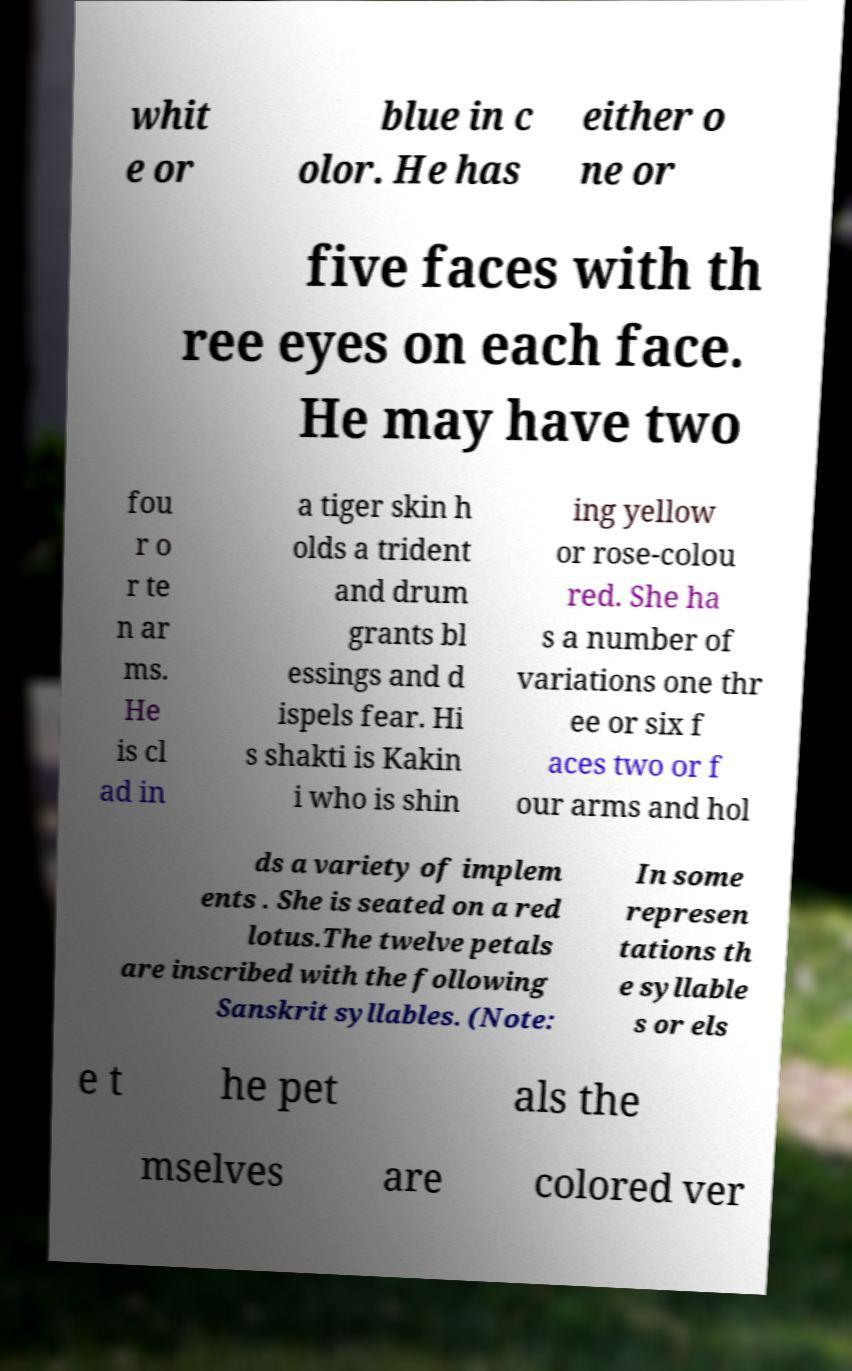Please identify and transcribe the text found in this image. whit e or blue in c olor. He has either o ne or five faces with th ree eyes on each face. He may have two fou r o r te n ar ms. He is cl ad in a tiger skin h olds a trident and drum grants bl essings and d ispels fear. Hi s shakti is Kakin i who is shin ing yellow or rose-colou red. She ha s a number of variations one thr ee or six f aces two or f our arms and hol ds a variety of implem ents . She is seated on a red lotus.The twelve petals are inscribed with the following Sanskrit syllables. (Note: In some represen tations th e syllable s or els e t he pet als the mselves are colored ver 